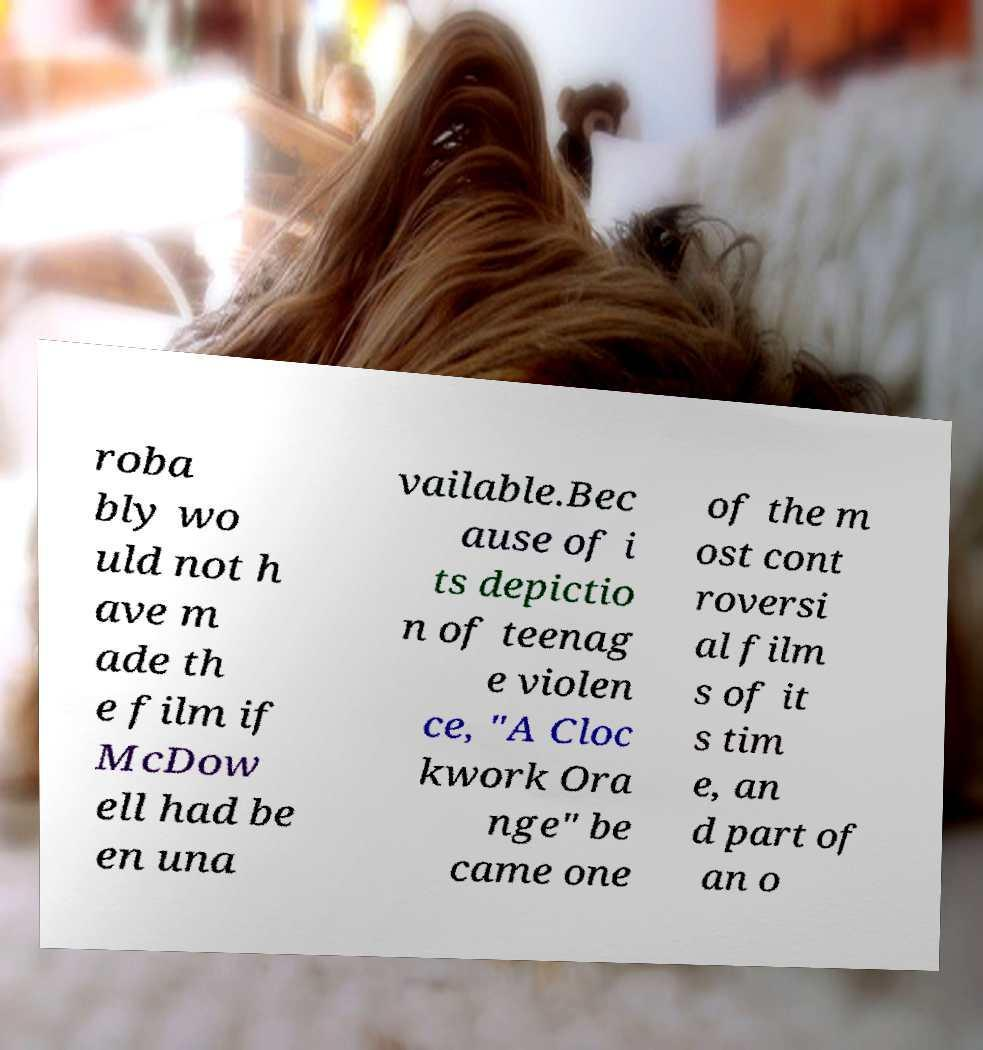There's text embedded in this image that I need extracted. Can you transcribe it verbatim? roba bly wo uld not h ave m ade th e film if McDow ell had be en una vailable.Bec ause of i ts depictio n of teenag e violen ce, "A Cloc kwork Ora nge" be came one of the m ost cont roversi al film s of it s tim e, an d part of an o 